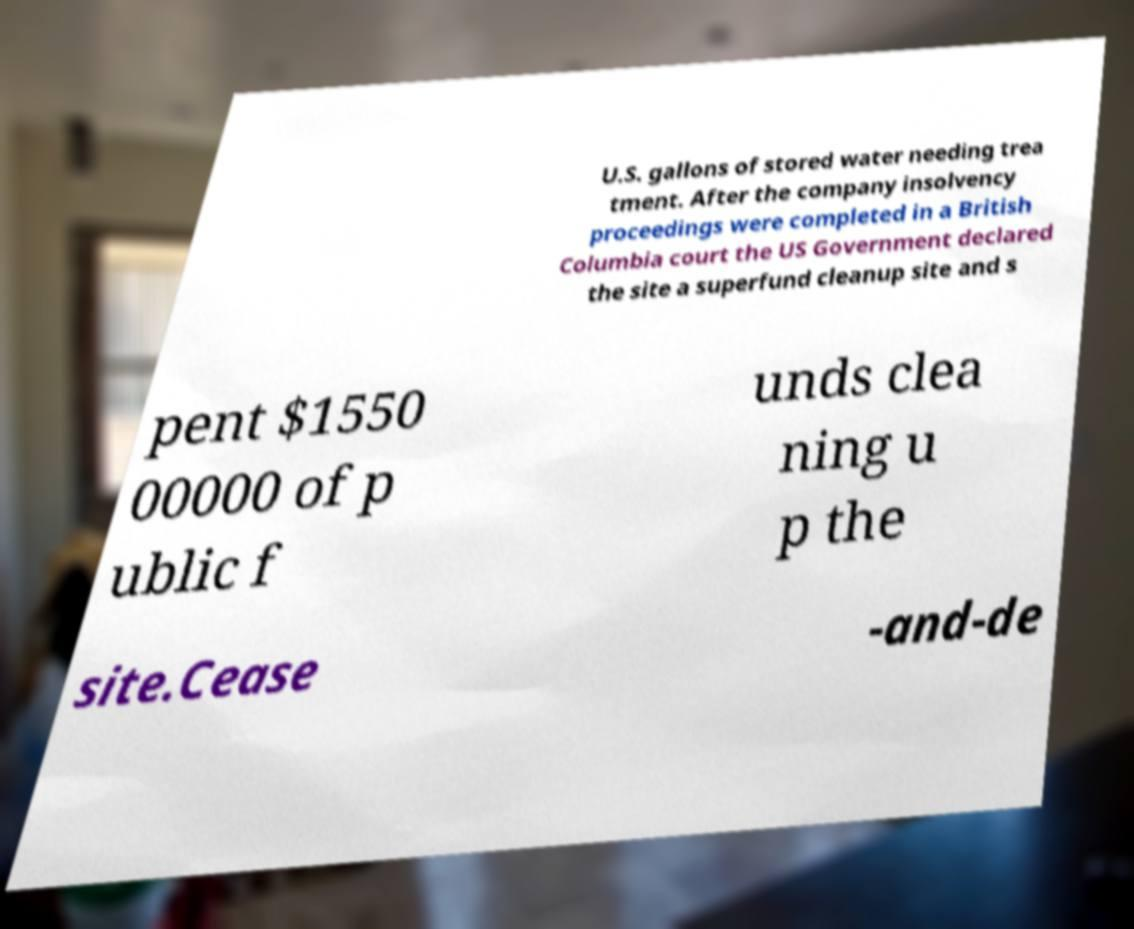For documentation purposes, I need the text within this image transcribed. Could you provide that? U.S. gallons of stored water needing trea tment. After the company insolvency proceedings were completed in a British Columbia court the US Government declared the site a superfund cleanup site and s pent $1550 00000 of p ublic f unds clea ning u p the site.Cease -and-de 